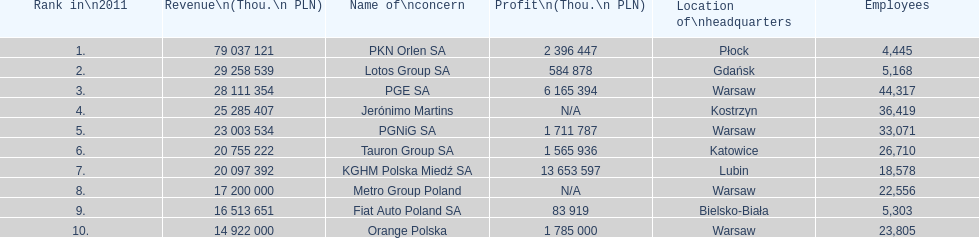Which company had the least revenue? Orange Polska. 